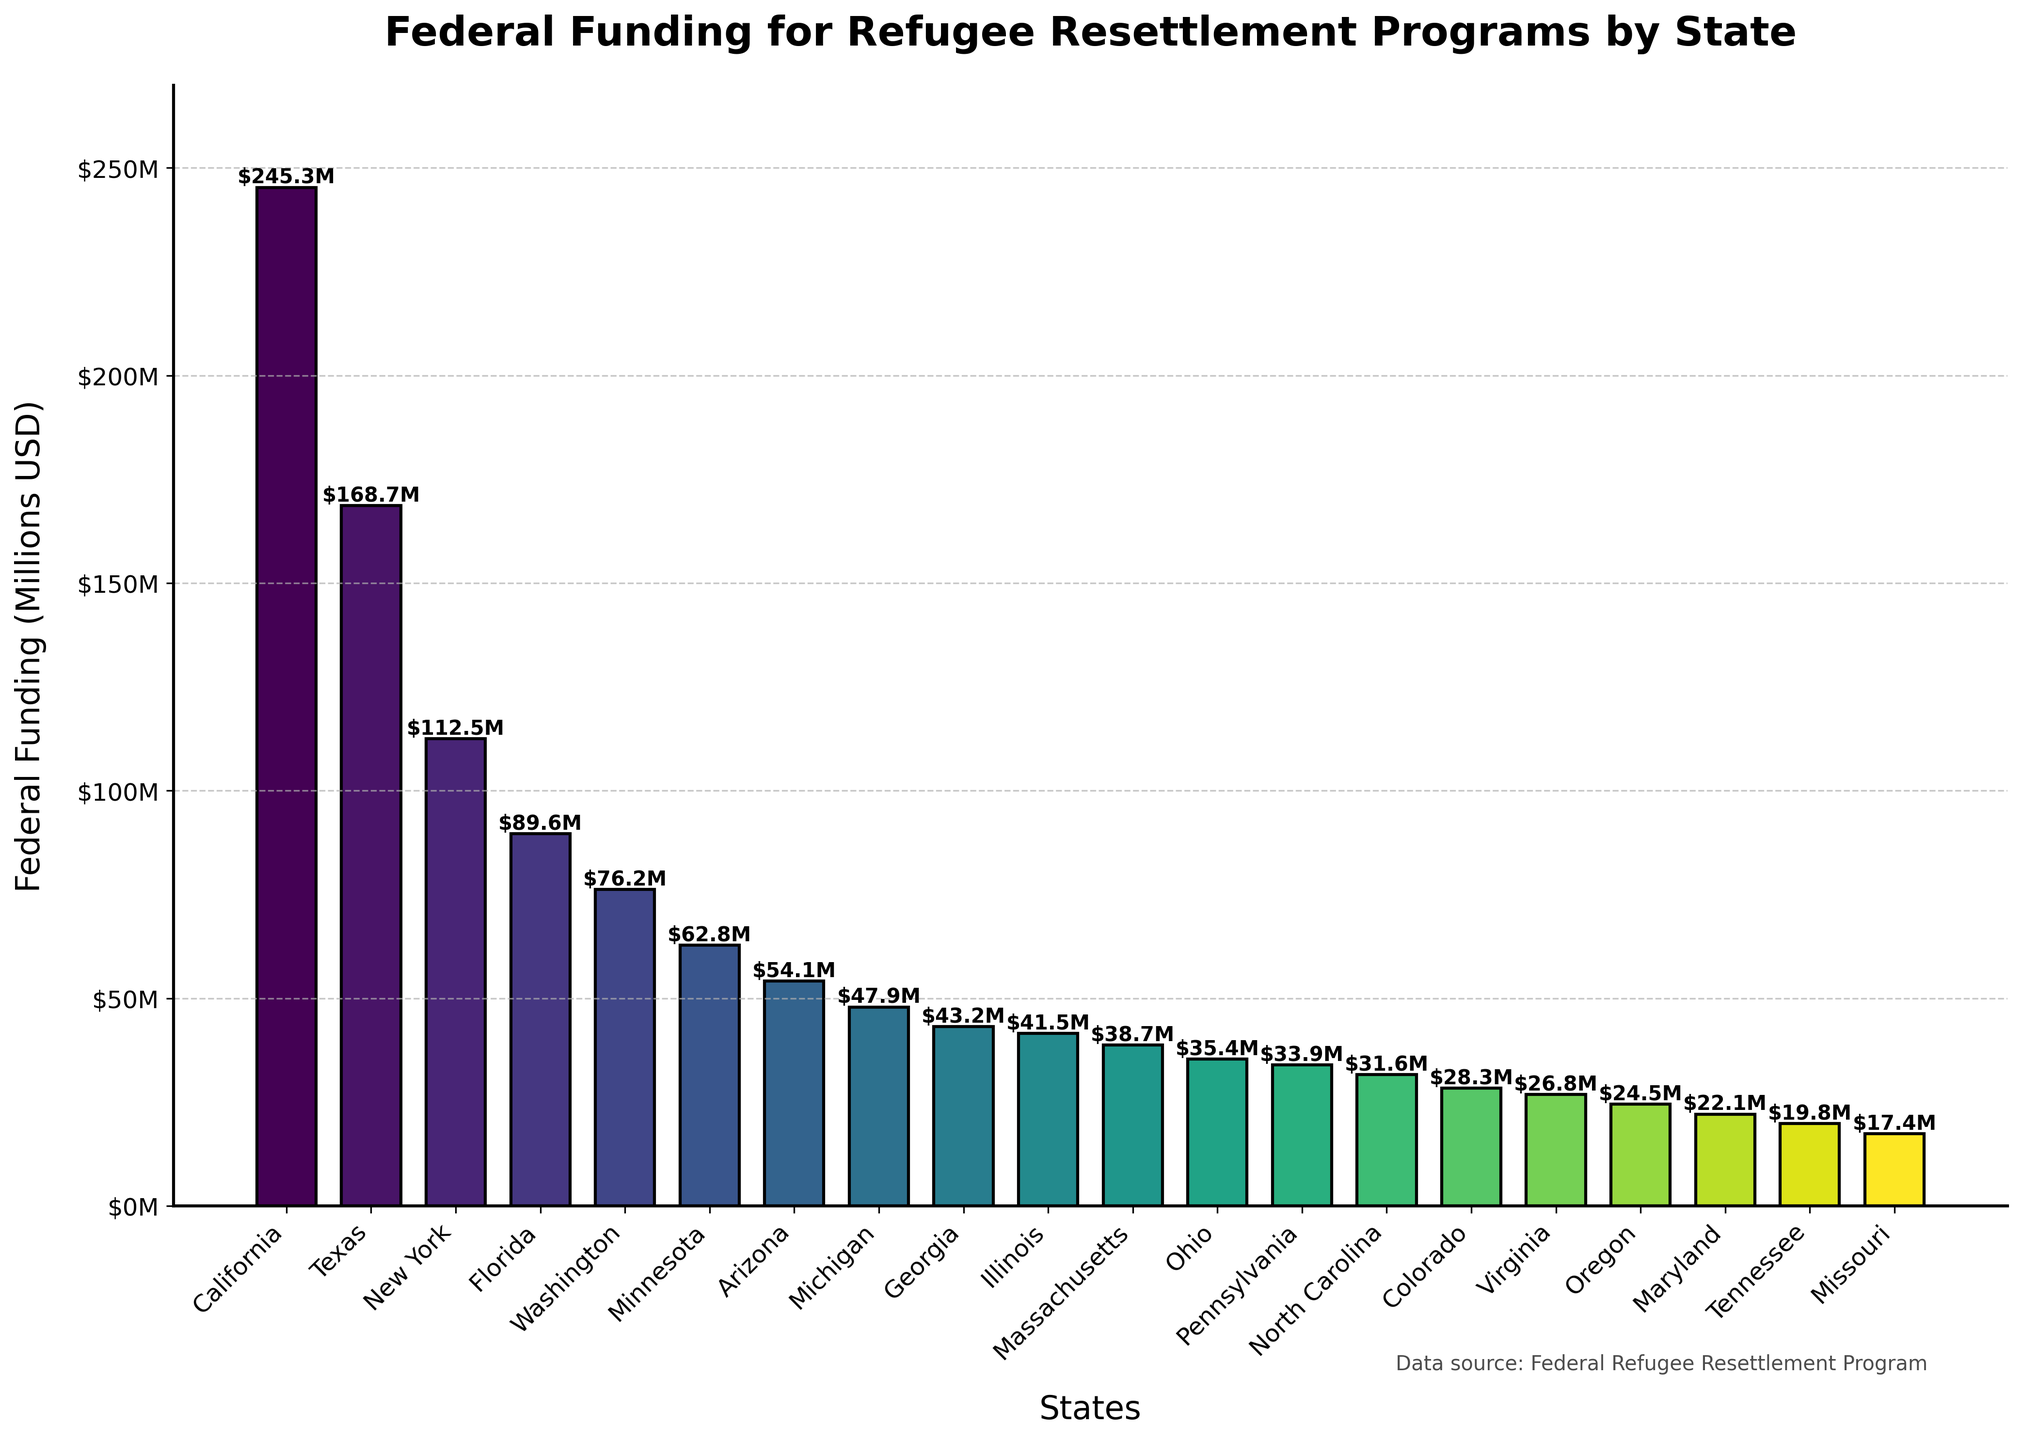What state receives the highest federal funding for refugee resettlement programs? The bar for California is the tallest in the figure, indicating it receives the highest federal funding.
Answer: California How does the federal funding for Texas compare to that for New York? Texas has a bar height that corresponds to $168.7 million while New York has a bar height corresponding to $112.5 million. Texas receives more federal funding than New York.
Answer: Texas receives more federal funding than New York Which states receive less than $40 million in federal funding? By examining the bars that fall below the $40 million mark on the y-axis, the states identified are Massachusetts, Ohio, Pennsylvania, North Carolina, Colorado, Virginia, Oregon, Maryland, Tennessee, and Missouri.
Answer: Massachusetts, Ohio, Pennsylvania, North Carolina, Colorado, Virginia, Oregon, Maryland, Tennessee, Missouri What is the difference in federal funding between Florida and Washington? Florida has a bar corresponding to $89.6 million and Washington has a bar corresponding to $76.2 million. The difference is calculated as $89.6 million - $76.2 million = $13.4 million.
Answer: $13.4 million What is the sum of federal funding for the top two states? The top two states by federal funding are California ($245.3 million) and Texas ($168.7 million). The sum is $245.3 million + $168.7 million = $414 million.
Answer: $414 million How many states receive more than $50 million in federal funding? By identifying bars higher than the $50 million mark, the states are California, Texas, New York, Florida, Washington, Minnesota, and Arizona.
Answer: 7 states What is the average federal funding for the bottom five states? The bottom five states by funding are Missouri ($17.4 million), Tennessee ($19.8 million), Maryland ($22.1 million), Oregon ($24.5 million), and Virginia ($26.8 million). The average is calculated as ($17.4M + $19.8M + $22.1M + $24.5M + $26.8M) / 5 = ($110.6M) / 5 = $22.12 million.
Answer: $22.12 million Which state receives slightly more funding: Georgia or Illinois? Georgia’s bar corresponds to $43.2 million and Illinois’ bar corresponds to $41.5 million. Georgia receives slightly more funding than Illinois.
Answer: Georgia What is the combined federal funding for Washington, Minnesota, and Arizona? The federal funding amounts are $76.2 million for Washington, $62.8 million for Minnesota, and $54.1 million for Arizona. The combined funding is $76.2M + $62.8M + $54.1M = $193.1 million.
Answer: $193.1 million Does Ohio receive more or less federal funding than Pennsylvania? Ohio has a bar corresponding to $35.4 million, whereas Pennsylvania has a bar corresponding to $33.9 million. Ohio receives more federal funding than Pennsylvania.
Answer: Ohio receives more 